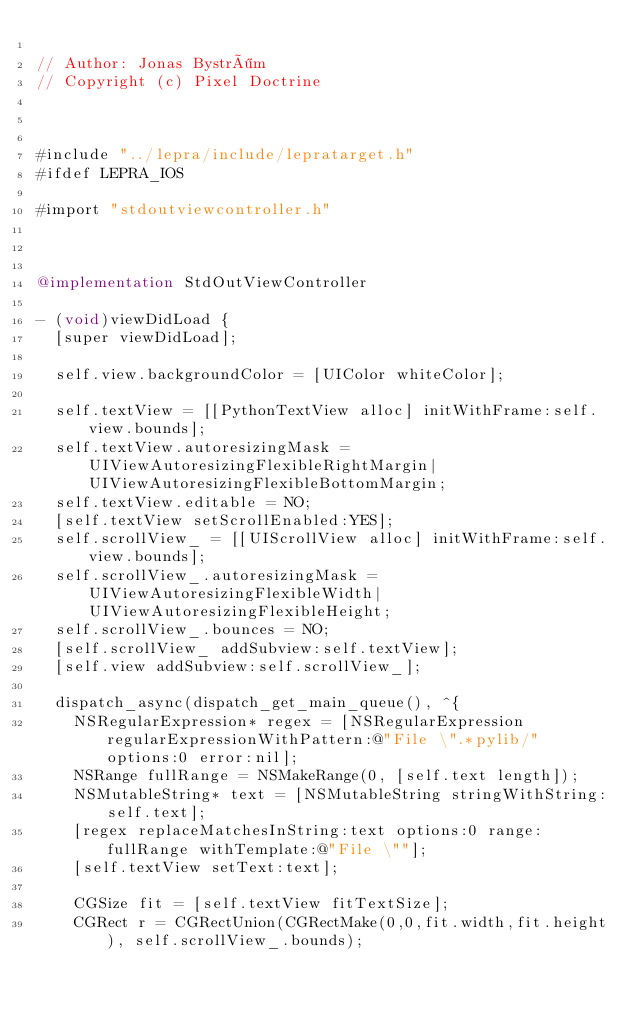Convert code to text. <code><loc_0><loc_0><loc_500><loc_500><_ObjectiveC_>
// Author: Jonas Byström
// Copyright (c) Pixel Doctrine



#include "../lepra/include/lepratarget.h"
#ifdef LEPRA_IOS

#import "stdoutviewcontroller.h"



@implementation StdOutViewController

- (void)viewDidLoad {
	[super viewDidLoad];

	self.view.backgroundColor = [UIColor whiteColor];

	self.textView = [[PythonTextView alloc] initWithFrame:self.view.bounds];
	self.textView.autoresizingMask = UIViewAutoresizingFlexibleRightMargin|UIViewAutoresizingFlexibleBottomMargin;
	self.textView.editable = NO;
	[self.textView setScrollEnabled:YES];
	self.scrollView_ = [[UIScrollView alloc] initWithFrame:self.view.bounds];
	self.scrollView_.autoresizingMask = UIViewAutoresizingFlexibleWidth|UIViewAutoresizingFlexibleHeight;
	self.scrollView_.bounces = NO;
	[self.scrollView_ addSubview:self.textView];
	[self.view addSubview:self.scrollView_];

	dispatch_async(dispatch_get_main_queue(), ^{
		NSRegularExpression* regex = [NSRegularExpression regularExpressionWithPattern:@"File \".*pylib/" options:0 error:nil];
		NSRange fullRange = NSMakeRange(0, [self.text length]);
		NSMutableString* text = [NSMutableString stringWithString:self.text];
		[regex replaceMatchesInString:text options:0 range:fullRange withTemplate:@"File \""];
		[self.textView setText:text];

		CGSize fit = [self.textView fitTextSize];
		CGRect r = CGRectUnion(CGRectMake(0,0,fit.width,fit.height), self.scrollView_.bounds);</code> 